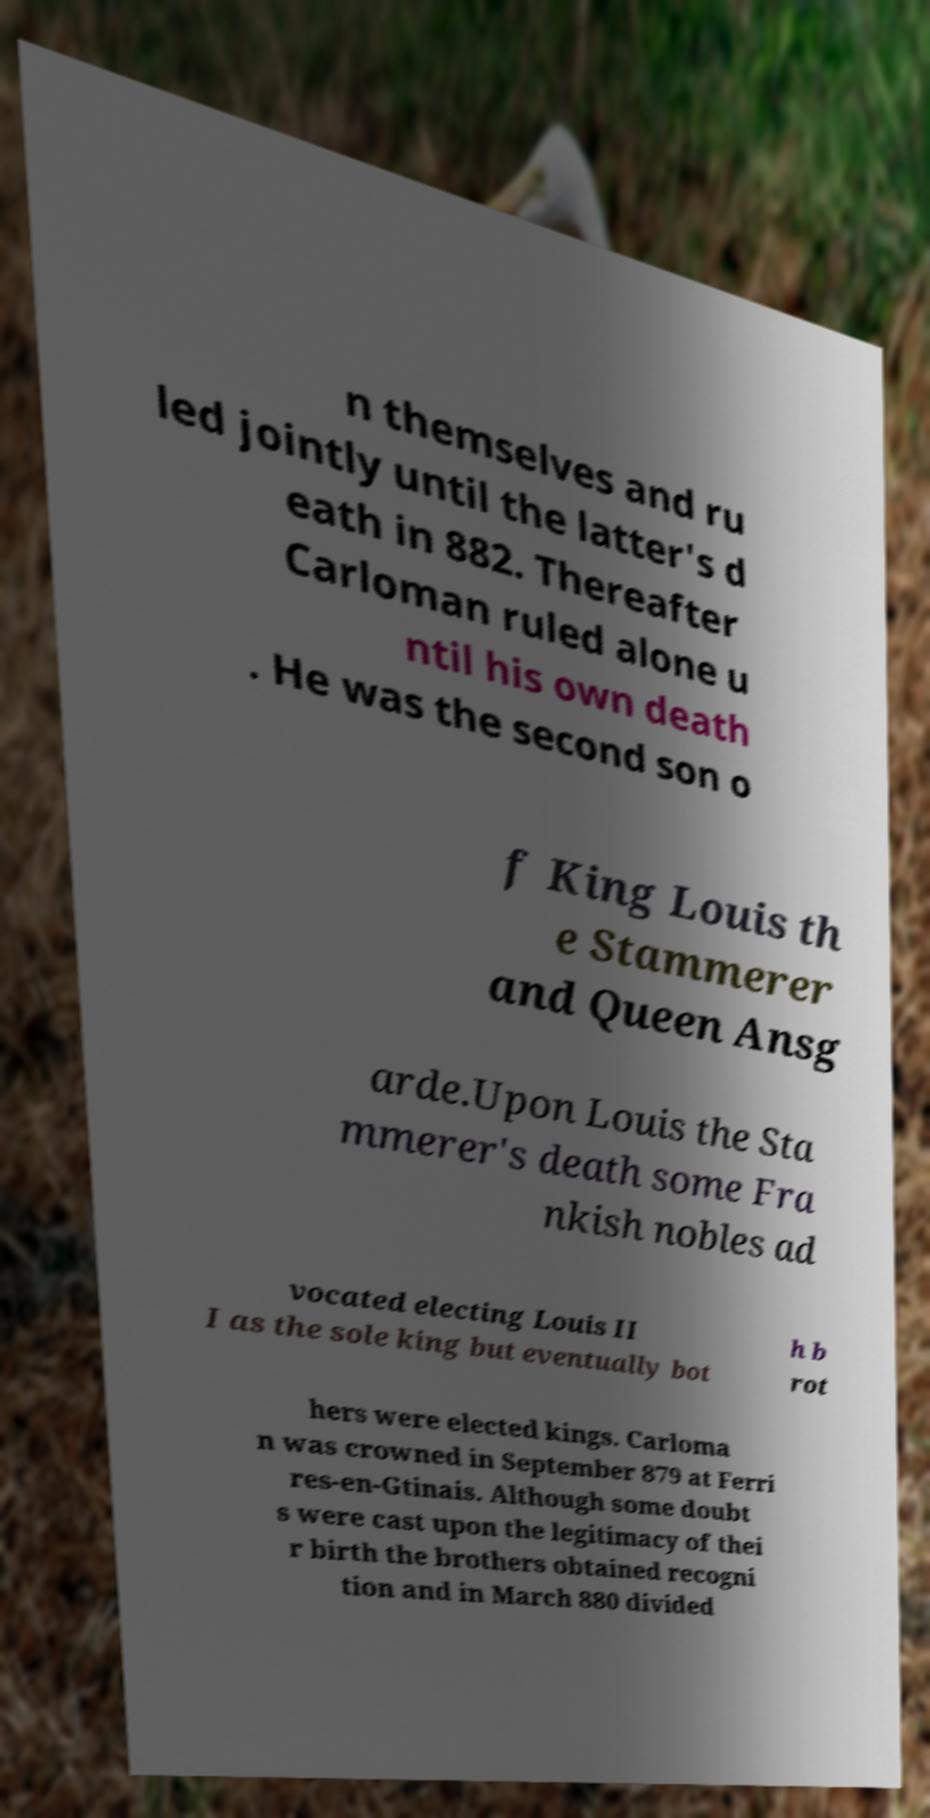Please identify and transcribe the text found in this image. n themselves and ru led jointly until the latter's d eath in 882. Thereafter Carloman ruled alone u ntil his own death . He was the second son o f King Louis th e Stammerer and Queen Ansg arde.Upon Louis the Sta mmerer's death some Fra nkish nobles ad vocated electing Louis II I as the sole king but eventually bot h b rot hers were elected kings. Carloma n was crowned in September 879 at Ferri res-en-Gtinais. Although some doubt s were cast upon the legitimacy of thei r birth the brothers obtained recogni tion and in March 880 divided 